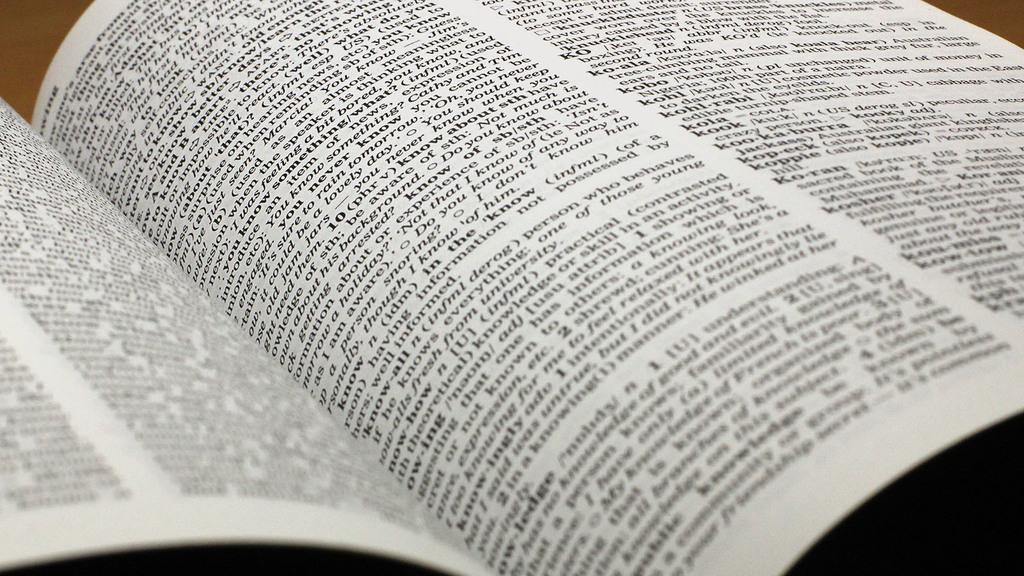What kind of book has descriptions of words like this?
Provide a succinct answer. Answering does not require reading text in the image. What word is above "kook?"?
Give a very brief answer. Kola. 